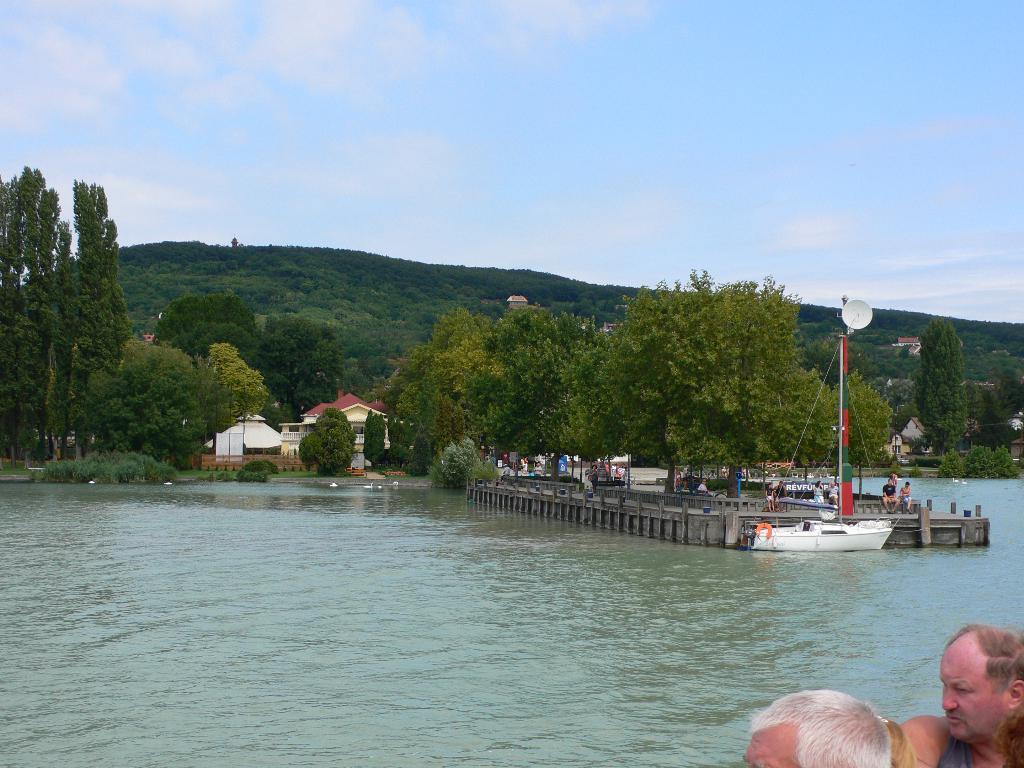Describe this image in one or two sentences. This is a water flowing. I think these are the houses. I can see the trees and bushes. This looks like a bridge. Here is a boat on the water. At the bottom right corner of the image, I can see two people. This looks like a hill, which is covered with the trees. 